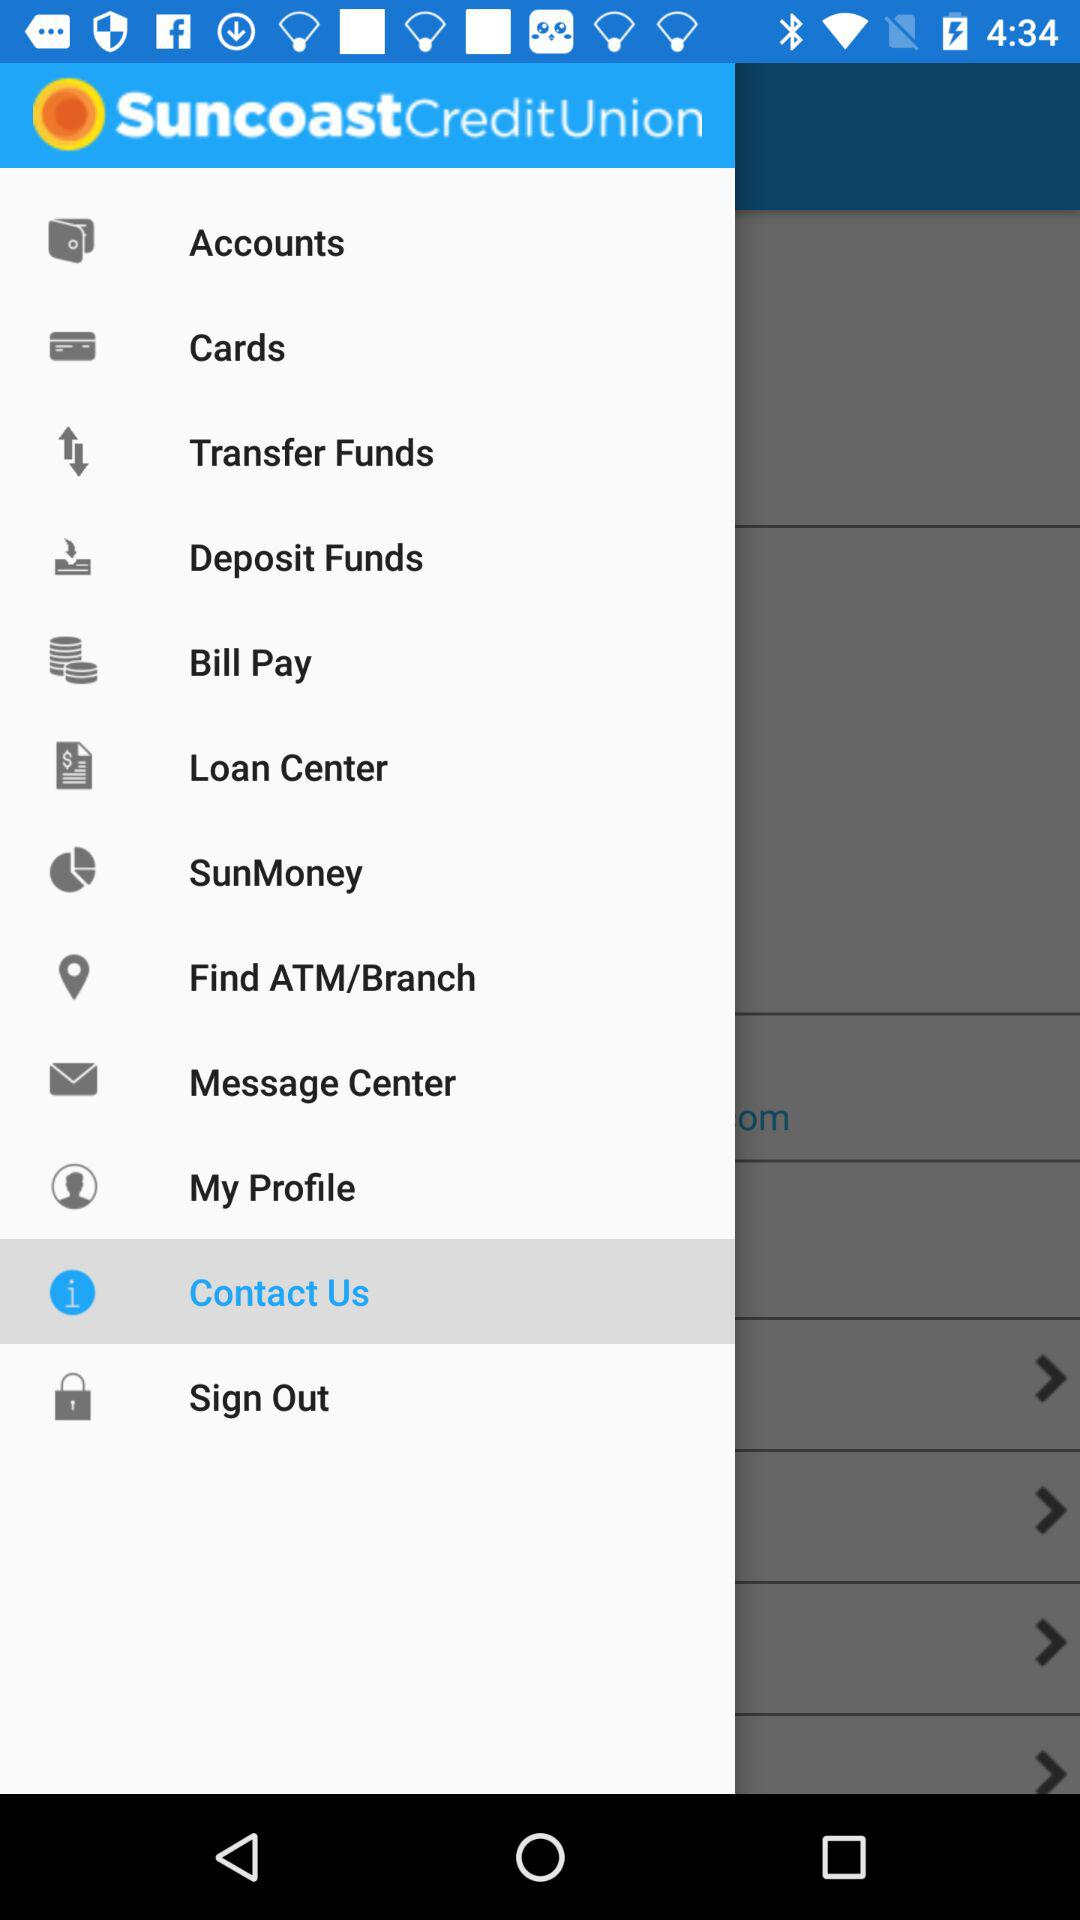What is the name of application? The name of the application is "SuncoastCreditUnion". 